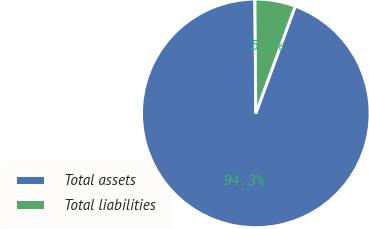<chart> <loc_0><loc_0><loc_500><loc_500><pie_chart><fcel>Total assets<fcel>Total liabilities<nl><fcel>94.27%<fcel>5.73%<nl></chart> 